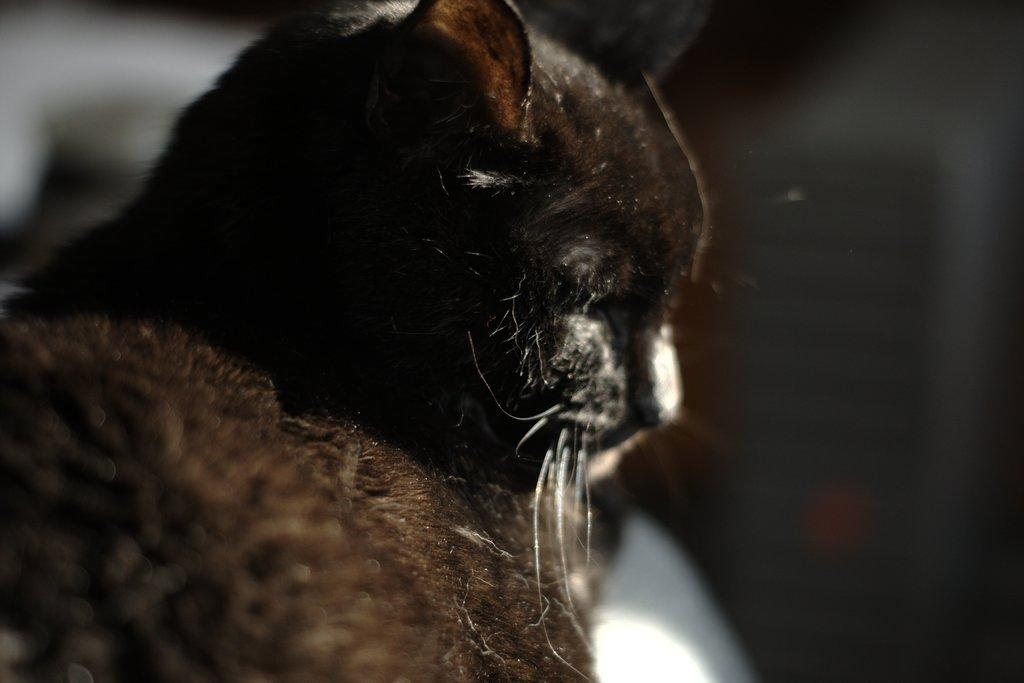What type of animal is present in the image? There is a cat in the picture. Can you describe the cat's appearance or behavior in the image? The provided facts do not mention any specific details about the cat's appearance or behavior. Is the cat in jail in the image? There is no mention of a jail or any confinement in the image, and the cat is not depicted as being in jail. What type of basket is the cat sitting in the image? There is no basket present in the image; it only features a cat. 